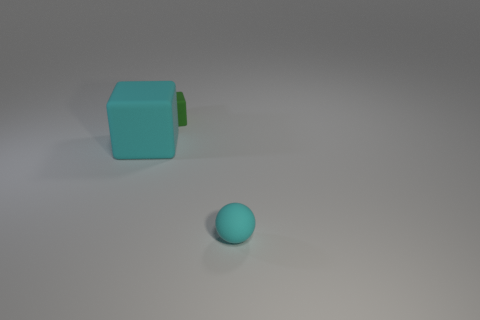How many tiny cyan things are the same material as the cyan block?
Provide a succinct answer. 1. What shape is the rubber thing that is in front of the tiny green object and behind the cyan ball?
Keep it short and to the point. Cube. Is the material of the tiny thing that is in front of the large matte thing the same as the green cube?
Keep it short and to the point. Yes. There is a rubber block that is the same size as the cyan sphere; what color is it?
Your answer should be compact. Green. Are there any matte things that have the same color as the sphere?
Offer a very short reply. Yes. What size is the block that is the same material as the tiny green thing?
Offer a very short reply. Large. The rubber block that is the same color as the tiny ball is what size?
Make the answer very short. Large. How many other things are the same size as the cyan cube?
Your response must be concise. 0. There is a thing that is in front of the cyan matte block; what material is it?
Give a very brief answer. Rubber. What is the shape of the big cyan thing in front of the tiny object that is on the left side of the small object that is on the right side of the green object?
Ensure brevity in your answer.  Cube. 